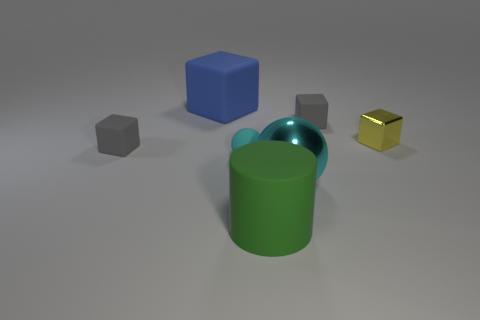How many other things are there of the same size as the green thing?
Offer a very short reply. 2. How many big green things are there?
Provide a succinct answer. 1. Is there anything else that is the same shape as the cyan metallic object?
Your response must be concise. Yes. Are the gray block that is to the left of the big cube and the tiny gray thing that is behind the tiny shiny thing made of the same material?
Ensure brevity in your answer.  Yes. What is the material of the big blue block?
Your response must be concise. Rubber. What number of gray blocks have the same material as the green cylinder?
Provide a succinct answer. 2. How many metal objects are either yellow things or balls?
Your answer should be very brief. 2. There is a tiny gray matte thing that is to the right of the small cyan matte sphere; does it have the same shape as the big rubber thing that is on the left side of the green rubber cylinder?
Your answer should be compact. Yes. What color is the rubber thing that is to the right of the cyan matte sphere and behind the large cyan object?
Make the answer very short. Gray. Is the size of the rubber ball that is to the right of the blue thing the same as the gray cube that is to the left of the cyan rubber thing?
Provide a short and direct response. Yes. 